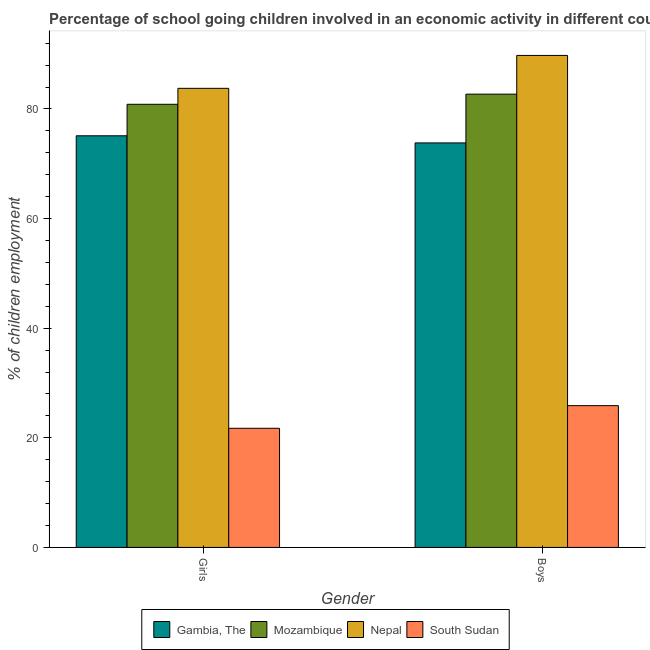How many different coloured bars are there?
Provide a short and direct response. 4. How many bars are there on the 2nd tick from the left?
Provide a succinct answer. 4. What is the label of the 2nd group of bars from the left?
Provide a short and direct response. Boys. What is the percentage of school going boys in Mozambique?
Provide a short and direct response. 82.7. Across all countries, what is the maximum percentage of school going girls?
Ensure brevity in your answer.  83.76. Across all countries, what is the minimum percentage of school going girls?
Give a very brief answer. 21.74. In which country was the percentage of school going girls maximum?
Ensure brevity in your answer.  Nepal. In which country was the percentage of school going girls minimum?
Offer a terse response. South Sudan. What is the total percentage of school going girls in the graph?
Offer a very short reply. 261.45. What is the difference between the percentage of school going boys in Gambia, The and that in Mozambique?
Your answer should be compact. -8.9. What is the difference between the percentage of school going girls in Gambia, The and the percentage of school going boys in Nepal?
Offer a very short reply. -14.66. What is the average percentage of school going girls per country?
Your response must be concise. 65.36. What is the difference between the percentage of school going boys and percentage of school going girls in Nepal?
Provide a short and direct response. 6. In how many countries, is the percentage of school going girls greater than 68 %?
Your answer should be compact. 3. What is the ratio of the percentage of school going boys in Nepal to that in South Sudan?
Give a very brief answer. 3.47. What does the 4th bar from the left in Girls represents?
Provide a succinct answer. South Sudan. What does the 2nd bar from the right in Boys represents?
Give a very brief answer. Nepal. How many bars are there?
Give a very brief answer. 8. How many countries are there in the graph?
Make the answer very short. 4. Are the values on the major ticks of Y-axis written in scientific E-notation?
Keep it short and to the point. No. Does the graph contain any zero values?
Provide a succinct answer. No. Does the graph contain grids?
Keep it short and to the point. No. Where does the legend appear in the graph?
Offer a very short reply. Bottom center. What is the title of the graph?
Ensure brevity in your answer.  Percentage of school going children involved in an economic activity in different countries. Does "Latvia" appear as one of the legend labels in the graph?
Offer a very short reply. No. What is the label or title of the X-axis?
Provide a succinct answer. Gender. What is the label or title of the Y-axis?
Give a very brief answer. % of children employment. What is the % of children employment of Gambia, The in Girls?
Provide a short and direct response. 75.1. What is the % of children employment of Mozambique in Girls?
Provide a short and direct response. 80.85. What is the % of children employment of Nepal in Girls?
Ensure brevity in your answer.  83.76. What is the % of children employment in South Sudan in Girls?
Your answer should be very brief. 21.74. What is the % of children employment in Gambia, The in Boys?
Provide a succinct answer. 73.8. What is the % of children employment of Mozambique in Boys?
Your answer should be compact. 82.7. What is the % of children employment of Nepal in Boys?
Make the answer very short. 89.76. What is the % of children employment in South Sudan in Boys?
Your answer should be very brief. 25.87. Across all Gender, what is the maximum % of children employment in Gambia, The?
Your response must be concise. 75.1. Across all Gender, what is the maximum % of children employment in Mozambique?
Your answer should be very brief. 82.7. Across all Gender, what is the maximum % of children employment of Nepal?
Provide a succinct answer. 89.76. Across all Gender, what is the maximum % of children employment of South Sudan?
Offer a terse response. 25.87. Across all Gender, what is the minimum % of children employment of Gambia, The?
Provide a succinct answer. 73.8. Across all Gender, what is the minimum % of children employment of Mozambique?
Keep it short and to the point. 80.85. Across all Gender, what is the minimum % of children employment in Nepal?
Make the answer very short. 83.76. Across all Gender, what is the minimum % of children employment in South Sudan?
Your response must be concise. 21.74. What is the total % of children employment in Gambia, The in the graph?
Keep it short and to the point. 148.9. What is the total % of children employment in Mozambique in the graph?
Offer a very short reply. 163.55. What is the total % of children employment of Nepal in the graph?
Offer a very short reply. 173.52. What is the total % of children employment of South Sudan in the graph?
Make the answer very short. 47.6. What is the difference between the % of children employment of Mozambique in Girls and that in Boys?
Offer a terse response. -1.85. What is the difference between the % of children employment of Nepal in Girls and that in Boys?
Keep it short and to the point. -6. What is the difference between the % of children employment in South Sudan in Girls and that in Boys?
Give a very brief answer. -4.13. What is the difference between the % of children employment of Gambia, The in Girls and the % of children employment of Mozambique in Boys?
Offer a very short reply. -7.6. What is the difference between the % of children employment of Gambia, The in Girls and the % of children employment of Nepal in Boys?
Keep it short and to the point. -14.66. What is the difference between the % of children employment in Gambia, The in Girls and the % of children employment in South Sudan in Boys?
Ensure brevity in your answer.  49.23. What is the difference between the % of children employment of Mozambique in Girls and the % of children employment of Nepal in Boys?
Your response must be concise. -8.91. What is the difference between the % of children employment in Mozambique in Girls and the % of children employment in South Sudan in Boys?
Give a very brief answer. 54.98. What is the difference between the % of children employment in Nepal in Girls and the % of children employment in South Sudan in Boys?
Offer a terse response. 57.89. What is the average % of children employment in Gambia, The per Gender?
Your answer should be very brief. 74.45. What is the average % of children employment of Mozambique per Gender?
Give a very brief answer. 81.77. What is the average % of children employment in Nepal per Gender?
Provide a short and direct response. 86.76. What is the average % of children employment in South Sudan per Gender?
Your response must be concise. 23.8. What is the difference between the % of children employment of Gambia, The and % of children employment of Mozambique in Girls?
Your answer should be compact. -5.75. What is the difference between the % of children employment in Gambia, The and % of children employment in Nepal in Girls?
Keep it short and to the point. -8.66. What is the difference between the % of children employment of Gambia, The and % of children employment of South Sudan in Girls?
Ensure brevity in your answer.  53.36. What is the difference between the % of children employment of Mozambique and % of children employment of Nepal in Girls?
Offer a terse response. -2.91. What is the difference between the % of children employment in Mozambique and % of children employment in South Sudan in Girls?
Your response must be concise. 59.11. What is the difference between the % of children employment of Nepal and % of children employment of South Sudan in Girls?
Give a very brief answer. 62.02. What is the difference between the % of children employment of Gambia, The and % of children employment of Mozambique in Boys?
Provide a short and direct response. -8.9. What is the difference between the % of children employment in Gambia, The and % of children employment in Nepal in Boys?
Your response must be concise. -15.96. What is the difference between the % of children employment of Gambia, The and % of children employment of South Sudan in Boys?
Keep it short and to the point. 47.93. What is the difference between the % of children employment in Mozambique and % of children employment in Nepal in Boys?
Keep it short and to the point. -7.07. What is the difference between the % of children employment in Mozambique and % of children employment in South Sudan in Boys?
Ensure brevity in your answer.  56.83. What is the difference between the % of children employment of Nepal and % of children employment of South Sudan in Boys?
Your response must be concise. 63.9. What is the ratio of the % of children employment in Gambia, The in Girls to that in Boys?
Offer a terse response. 1.02. What is the ratio of the % of children employment in Mozambique in Girls to that in Boys?
Make the answer very short. 0.98. What is the ratio of the % of children employment of Nepal in Girls to that in Boys?
Your response must be concise. 0.93. What is the ratio of the % of children employment of South Sudan in Girls to that in Boys?
Provide a succinct answer. 0.84. What is the difference between the highest and the second highest % of children employment in Mozambique?
Your answer should be very brief. 1.85. What is the difference between the highest and the second highest % of children employment in Nepal?
Make the answer very short. 6. What is the difference between the highest and the second highest % of children employment of South Sudan?
Keep it short and to the point. 4.13. What is the difference between the highest and the lowest % of children employment in Gambia, The?
Your answer should be very brief. 1.3. What is the difference between the highest and the lowest % of children employment in Mozambique?
Your response must be concise. 1.85. What is the difference between the highest and the lowest % of children employment in Nepal?
Provide a short and direct response. 6. What is the difference between the highest and the lowest % of children employment of South Sudan?
Offer a very short reply. 4.13. 